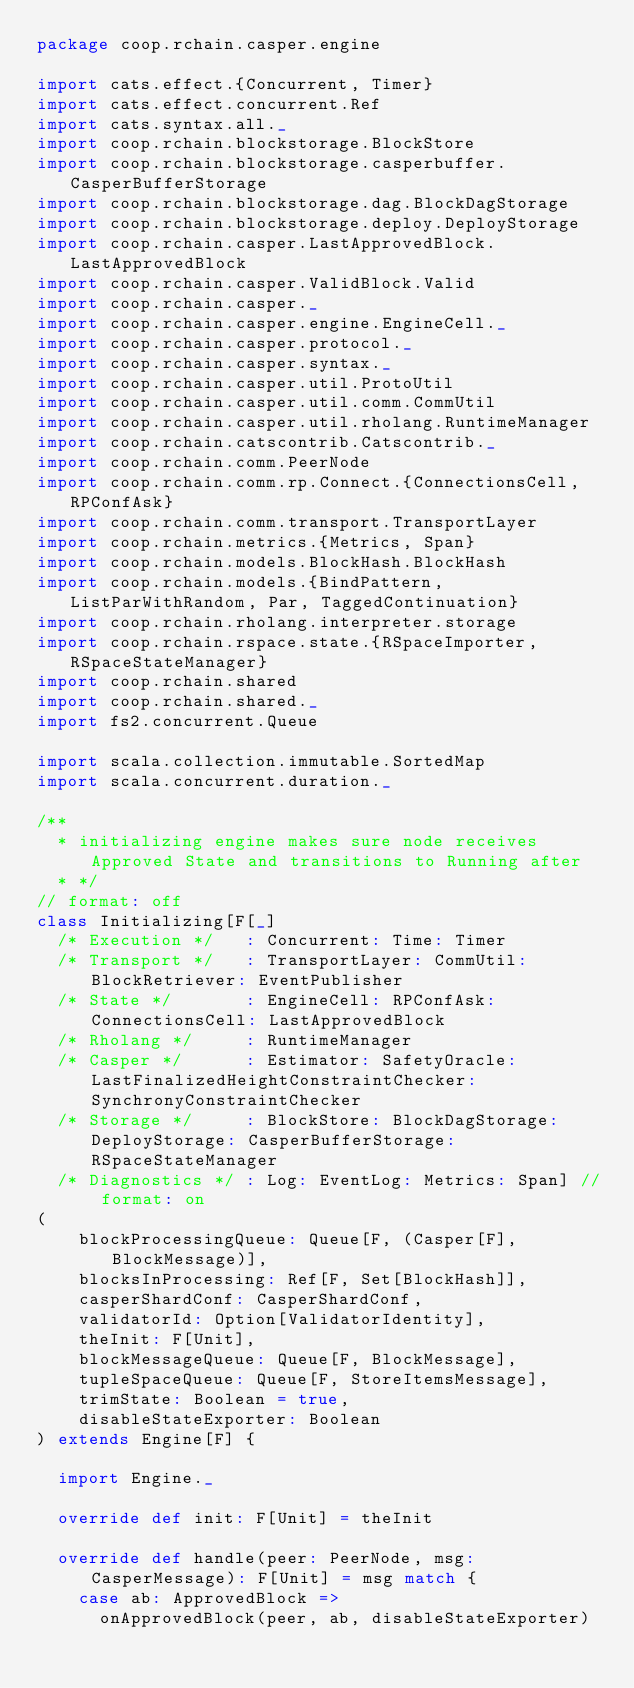Convert code to text. <code><loc_0><loc_0><loc_500><loc_500><_Scala_>package coop.rchain.casper.engine

import cats.effect.{Concurrent, Timer}
import cats.effect.concurrent.Ref
import cats.syntax.all._
import coop.rchain.blockstorage.BlockStore
import coop.rchain.blockstorage.casperbuffer.CasperBufferStorage
import coop.rchain.blockstorage.dag.BlockDagStorage
import coop.rchain.blockstorage.deploy.DeployStorage
import coop.rchain.casper.LastApprovedBlock.LastApprovedBlock
import coop.rchain.casper.ValidBlock.Valid
import coop.rchain.casper._
import coop.rchain.casper.engine.EngineCell._
import coop.rchain.casper.protocol._
import coop.rchain.casper.syntax._
import coop.rchain.casper.util.ProtoUtil
import coop.rchain.casper.util.comm.CommUtil
import coop.rchain.casper.util.rholang.RuntimeManager
import coop.rchain.catscontrib.Catscontrib._
import coop.rchain.comm.PeerNode
import coop.rchain.comm.rp.Connect.{ConnectionsCell, RPConfAsk}
import coop.rchain.comm.transport.TransportLayer
import coop.rchain.metrics.{Metrics, Span}
import coop.rchain.models.BlockHash.BlockHash
import coop.rchain.models.{BindPattern, ListParWithRandom, Par, TaggedContinuation}
import coop.rchain.rholang.interpreter.storage
import coop.rchain.rspace.state.{RSpaceImporter, RSpaceStateManager}
import coop.rchain.shared
import coop.rchain.shared._
import fs2.concurrent.Queue

import scala.collection.immutable.SortedMap
import scala.concurrent.duration._

/**
  * initializing engine makes sure node receives Approved State and transitions to Running after
  * */
// format: off
class Initializing[F[_]
  /* Execution */   : Concurrent: Time: Timer
  /* Transport */   : TransportLayer: CommUtil: BlockRetriever: EventPublisher
  /* State */       : EngineCell: RPConfAsk: ConnectionsCell: LastApprovedBlock
  /* Rholang */     : RuntimeManager
  /* Casper */      : Estimator: SafetyOracle: LastFinalizedHeightConstraintChecker: SynchronyConstraintChecker
  /* Storage */     : BlockStore: BlockDagStorage: DeployStorage: CasperBufferStorage: RSpaceStateManager
  /* Diagnostics */ : Log: EventLog: Metrics: Span] // format: on
(
    blockProcessingQueue: Queue[F, (Casper[F], BlockMessage)],
    blocksInProcessing: Ref[F, Set[BlockHash]],
    casperShardConf: CasperShardConf,
    validatorId: Option[ValidatorIdentity],
    theInit: F[Unit],
    blockMessageQueue: Queue[F, BlockMessage],
    tupleSpaceQueue: Queue[F, StoreItemsMessage],
    trimState: Boolean = true,
    disableStateExporter: Boolean
) extends Engine[F] {

  import Engine._

  override def init: F[Unit] = theInit

  override def handle(peer: PeerNode, msg: CasperMessage): F[Unit] = msg match {
    case ab: ApprovedBlock =>
      onApprovedBlock(peer, ab, disableStateExporter)</code> 